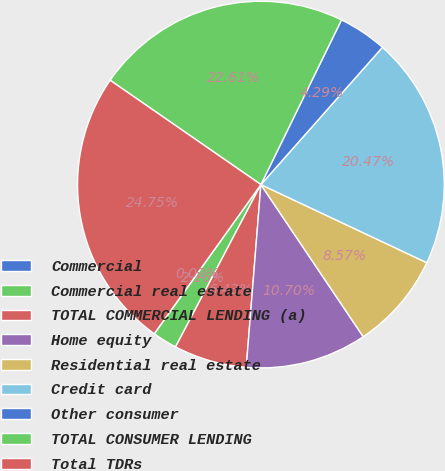Convert chart to OTSL. <chart><loc_0><loc_0><loc_500><loc_500><pie_chart><fcel>Commercial<fcel>Commercial real estate<fcel>TOTAL COMMERCIAL LENDING (a)<fcel>Home equity<fcel>Residential real estate<fcel>Credit card<fcel>Other consumer<fcel>TOTAL CONSUMER LENDING<fcel>Total TDRs<nl><fcel>0.02%<fcel>2.16%<fcel>6.43%<fcel>10.7%<fcel>8.57%<fcel>20.47%<fcel>4.29%<fcel>22.61%<fcel>24.75%<nl></chart> 